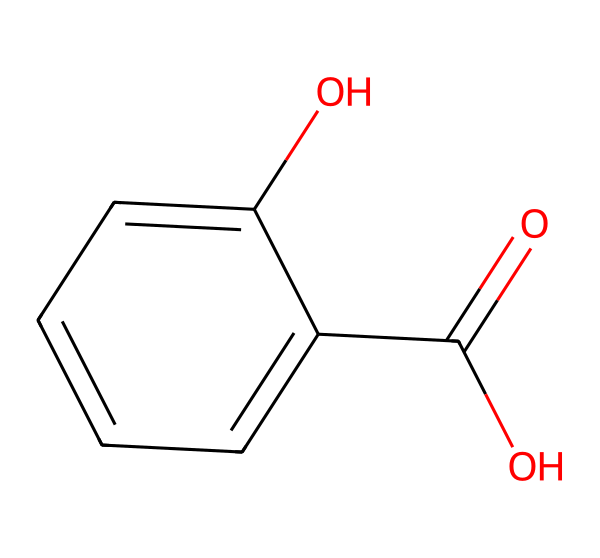What is the common name for this chemical? The SMILES representation indicates the molecular structure of salicylic acid, which is commonly derived from willow bark and widely used in acne treatment.
Answer: salicylic acid How many carbon atoms are in salicylic acid? By analyzing the structure, we can count the carbon atoms present. The structure shows six carbon atoms from the benzene ring and one from the carboxylic group, totaling seven.
Answer: seven What functional groups are present in salicylic acid? In the given chemical structure, there are a carboxylic acid group (-COOH) and a hydroxyl group (-OH) attached to the aromatic ring, indicating both functional groups.
Answer: carboxylic acid and hydroxyl How many hydrogen atoms are attached in total? From the structure, you can deduce that there are three hydrogen atoms present on the benzene ring and one from the hydroxyl group, with one more from the carboxylic group. Thus, there are a total of four hydrogen atoms attached.
Answer: four What property does salicylic acid impart to cosmetic products? The presence of the hydroxyl group contributes to the chemical's ability to exfoliate and penetrate the skin effectively, making it popular in dermatological applications.
Answer: exfoliating Is salicylic acid a natural or synthetic product? Salicylic acid can be sourced from natural willow bark, making it a naturally derived compound, though it can also be synthesized in a lab.
Answer: natural 